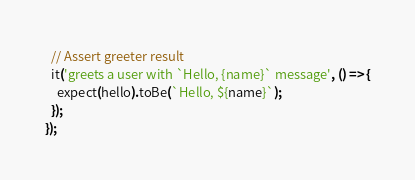<code> <loc_0><loc_0><loc_500><loc_500><_TypeScript_>
  // Assert greeter result
  it('greets a user with `Hello, {name}` message', () => {
    expect(hello).toBe(`Hello, ${name}`);
  });
});
</code> 